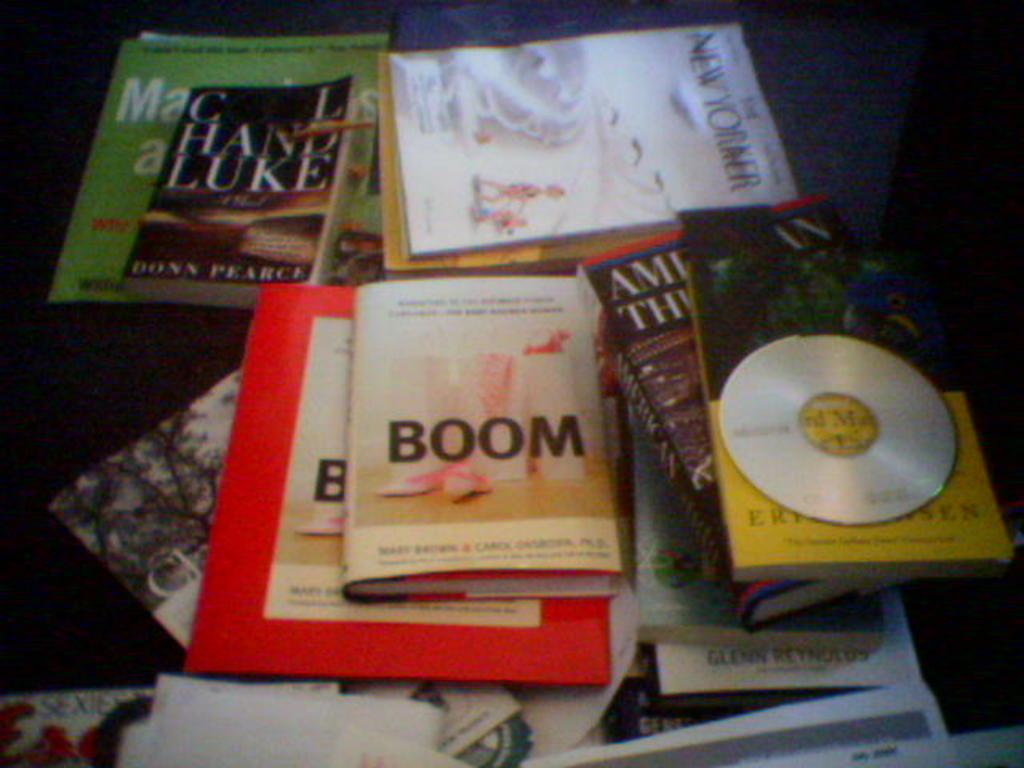<image>
Share a concise interpretation of the image provided. Book called BOOM on top of some other books and next to a CD. 